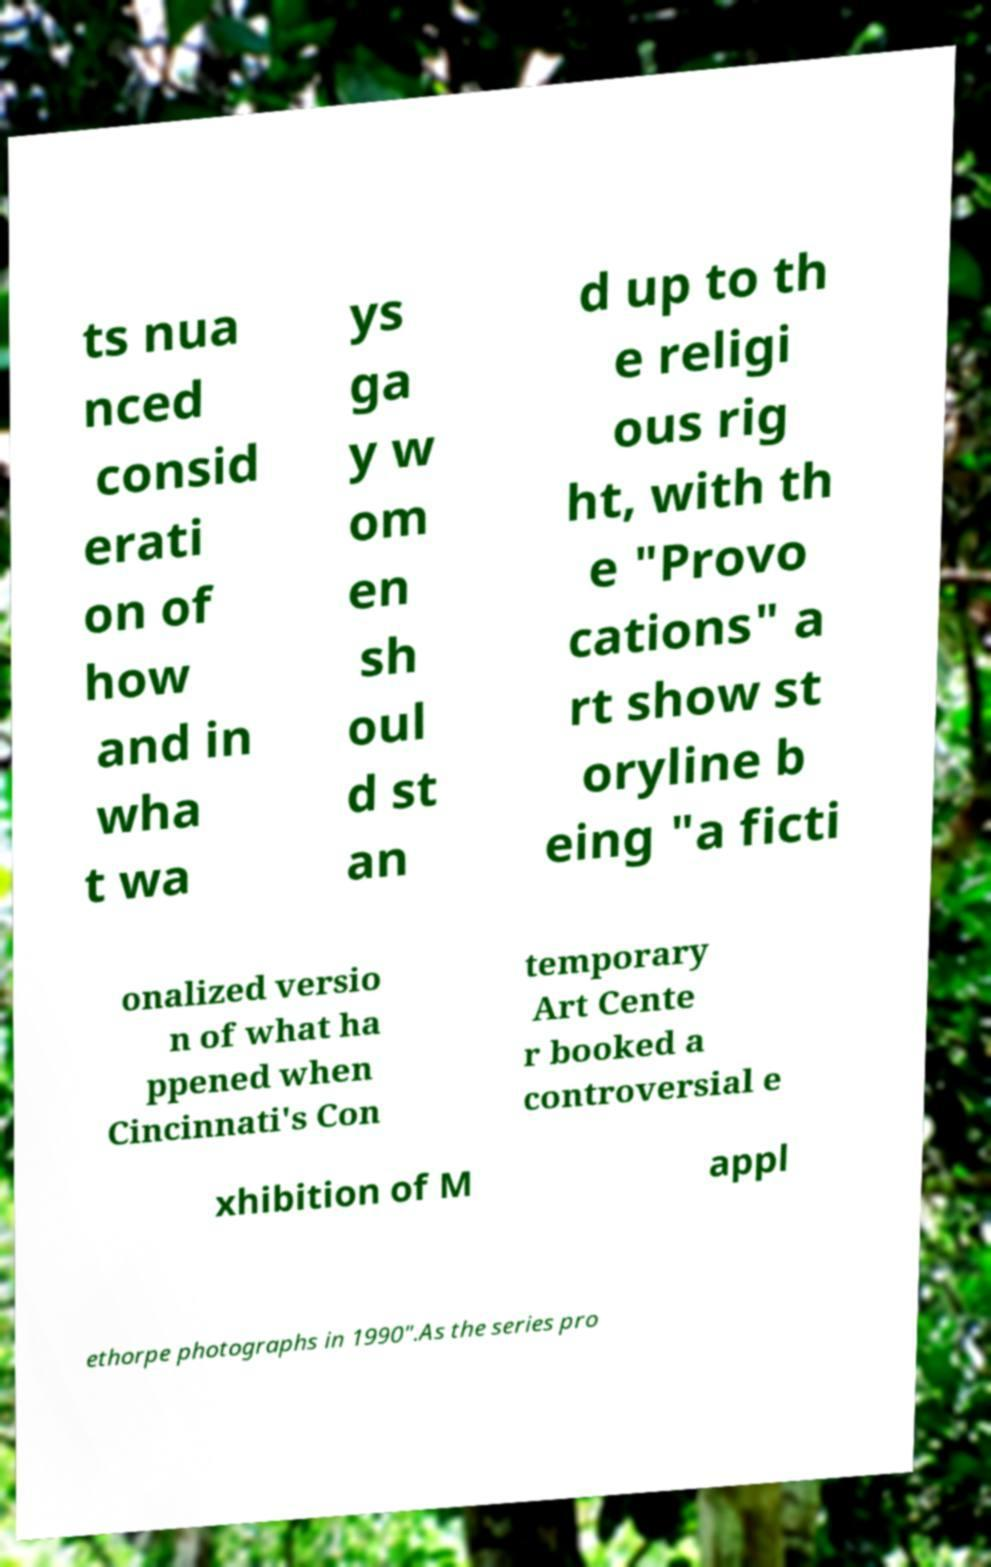Could you assist in decoding the text presented in this image and type it out clearly? ts nua nced consid erati on of how and in wha t wa ys ga y w om en sh oul d st an d up to th e religi ous rig ht, with th e "Provo cations" a rt show st oryline b eing "a ficti onalized versio n of what ha ppened when Cincinnati's Con temporary Art Cente r booked a controversial e xhibition of M appl ethorpe photographs in 1990".As the series pro 